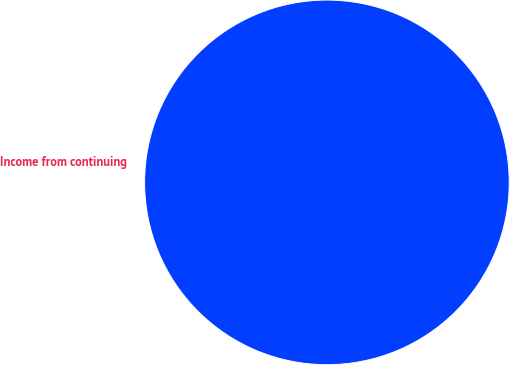<chart> <loc_0><loc_0><loc_500><loc_500><pie_chart><fcel>Income from continuing<nl><fcel>100.0%<nl></chart> 